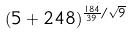Convert formula to latex. <formula><loc_0><loc_0><loc_500><loc_500>( 5 + 2 4 8 ) ^ { \frac { 1 8 4 } { 3 9 } / \sqrt { 9 } }</formula> 